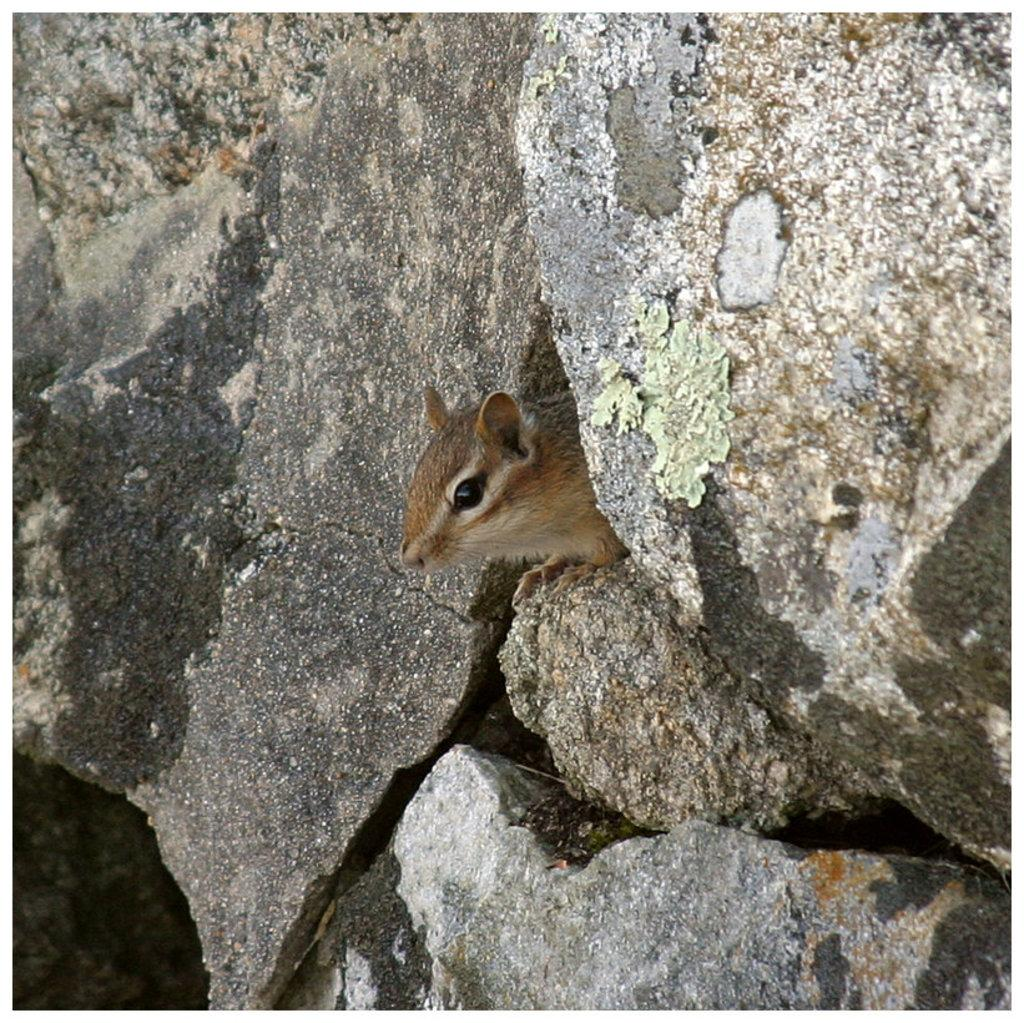What type of animal is present in the image? There is a mouse in the image. Where is the mouse located? The mouse is in rocks. Can you see any veins in the mouse's body in the image? There is no indication of visible veins in the mouse's body in the image. 